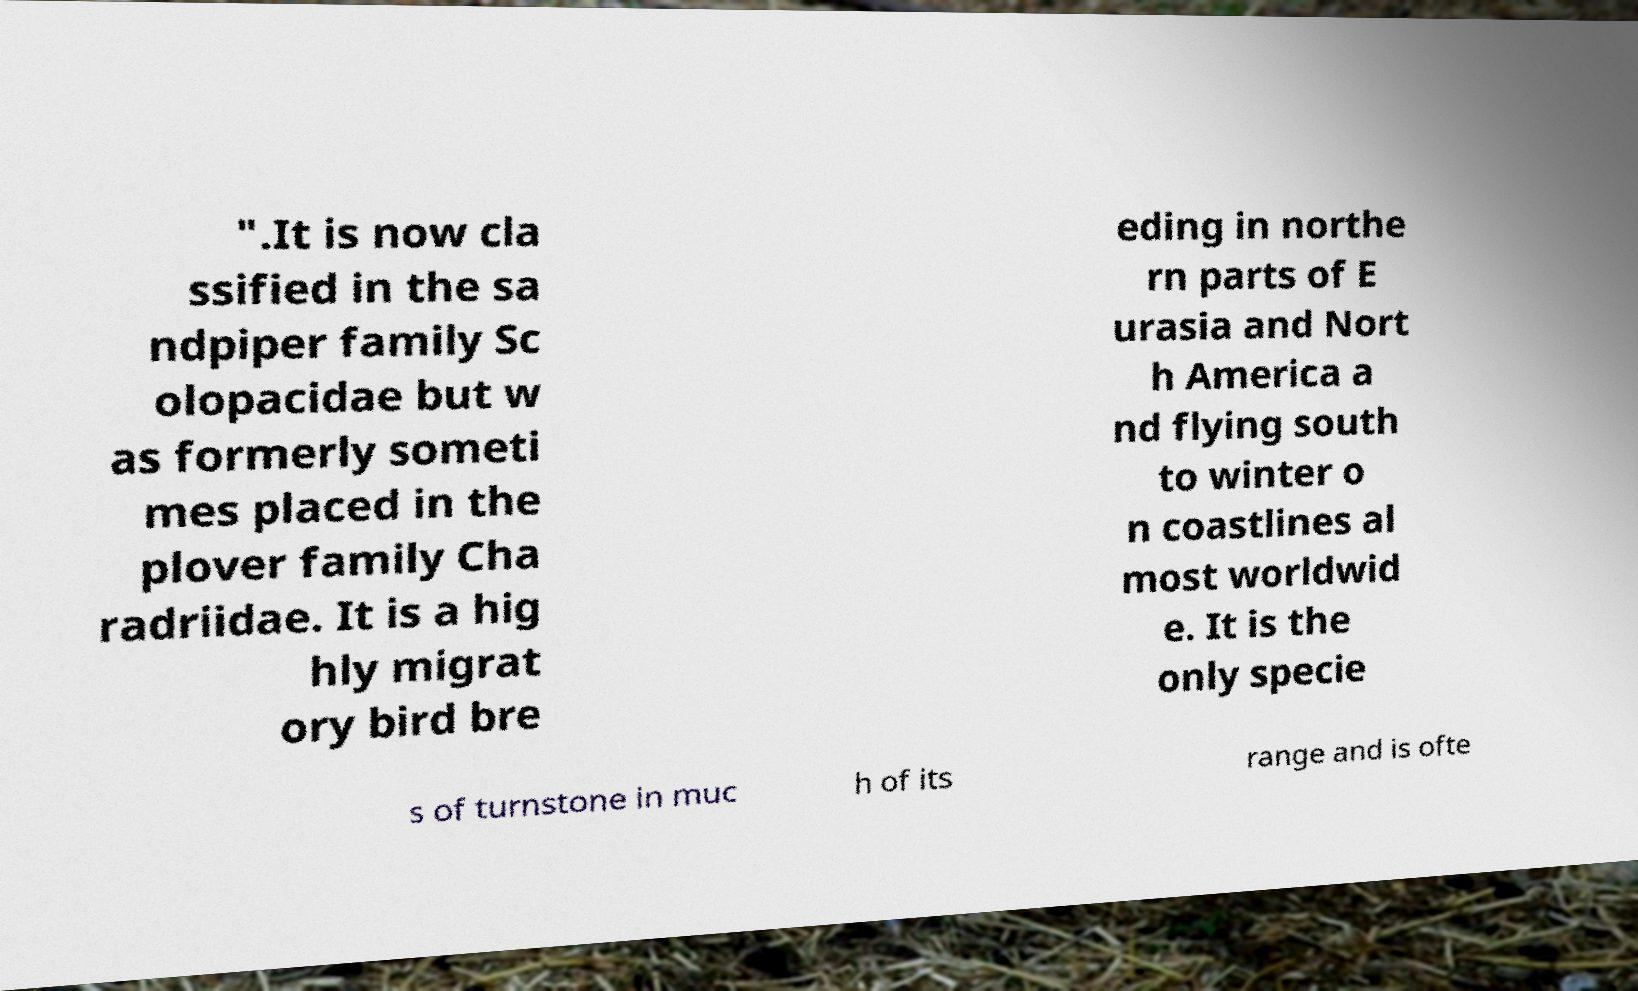I need the written content from this picture converted into text. Can you do that? ".It is now cla ssified in the sa ndpiper family Sc olopacidae but w as formerly someti mes placed in the plover family Cha radriidae. It is a hig hly migrat ory bird bre eding in northe rn parts of E urasia and Nort h America a nd flying south to winter o n coastlines al most worldwid e. It is the only specie s of turnstone in muc h of its range and is ofte 